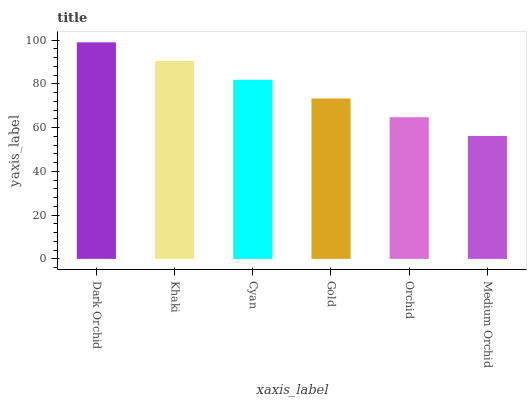Is Medium Orchid the minimum?
Answer yes or no. Yes. Is Dark Orchid the maximum?
Answer yes or no. Yes. Is Khaki the minimum?
Answer yes or no. No. Is Khaki the maximum?
Answer yes or no. No. Is Dark Orchid greater than Khaki?
Answer yes or no. Yes. Is Khaki less than Dark Orchid?
Answer yes or no. Yes. Is Khaki greater than Dark Orchid?
Answer yes or no. No. Is Dark Orchid less than Khaki?
Answer yes or no. No. Is Cyan the high median?
Answer yes or no. Yes. Is Gold the low median?
Answer yes or no. Yes. Is Orchid the high median?
Answer yes or no. No. Is Orchid the low median?
Answer yes or no. No. 